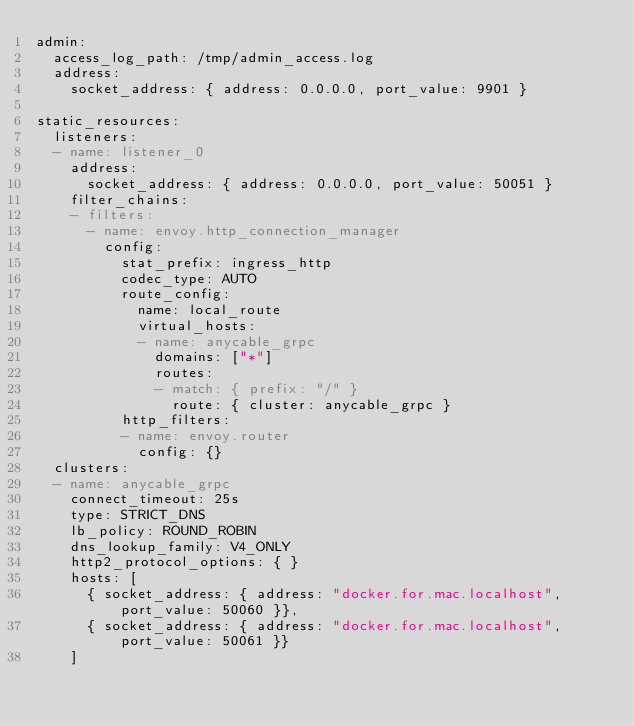<code> <loc_0><loc_0><loc_500><loc_500><_YAML_>admin:
  access_log_path: /tmp/admin_access.log
  address:
    socket_address: { address: 0.0.0.0, port_value: 9901 }

static_resources:
  listeners:
  - name: listener_0
    address:
      socket_address: { address: 0.0.0.0, port_value: 50051 }
    filter_chains:
    - filters:
      - name: envoy.http_connection_manager
        config:
          stat_prefix: ingress_http
          codec_type: AUTO
          route_config:
            name: local_route
            virtual_hosts:
            - name: anycable_grpc
              domains: ["*"]
              routes:
              - match: { prefix: "/" }
                route: { cluster: anycable_grpc }
          http_filters:
          - name: envoy.router
            config: {}
  clusters:
  - name: anycable_grpc
    connect_timeout: 25s
    type: STRICT_DNS
    lb_policy: ROUND_ROBIN
    dns_lookup_family: V4_ONLY
    http2_protocol_options: { }
    hosts: [
      { socket_address: { address: "docker.for.mac.localhost", port_value: 50060 }},
      { socket_address: { address: "docker.for.mac.localhost", port_value: 50061 }}
    ]
</code> 